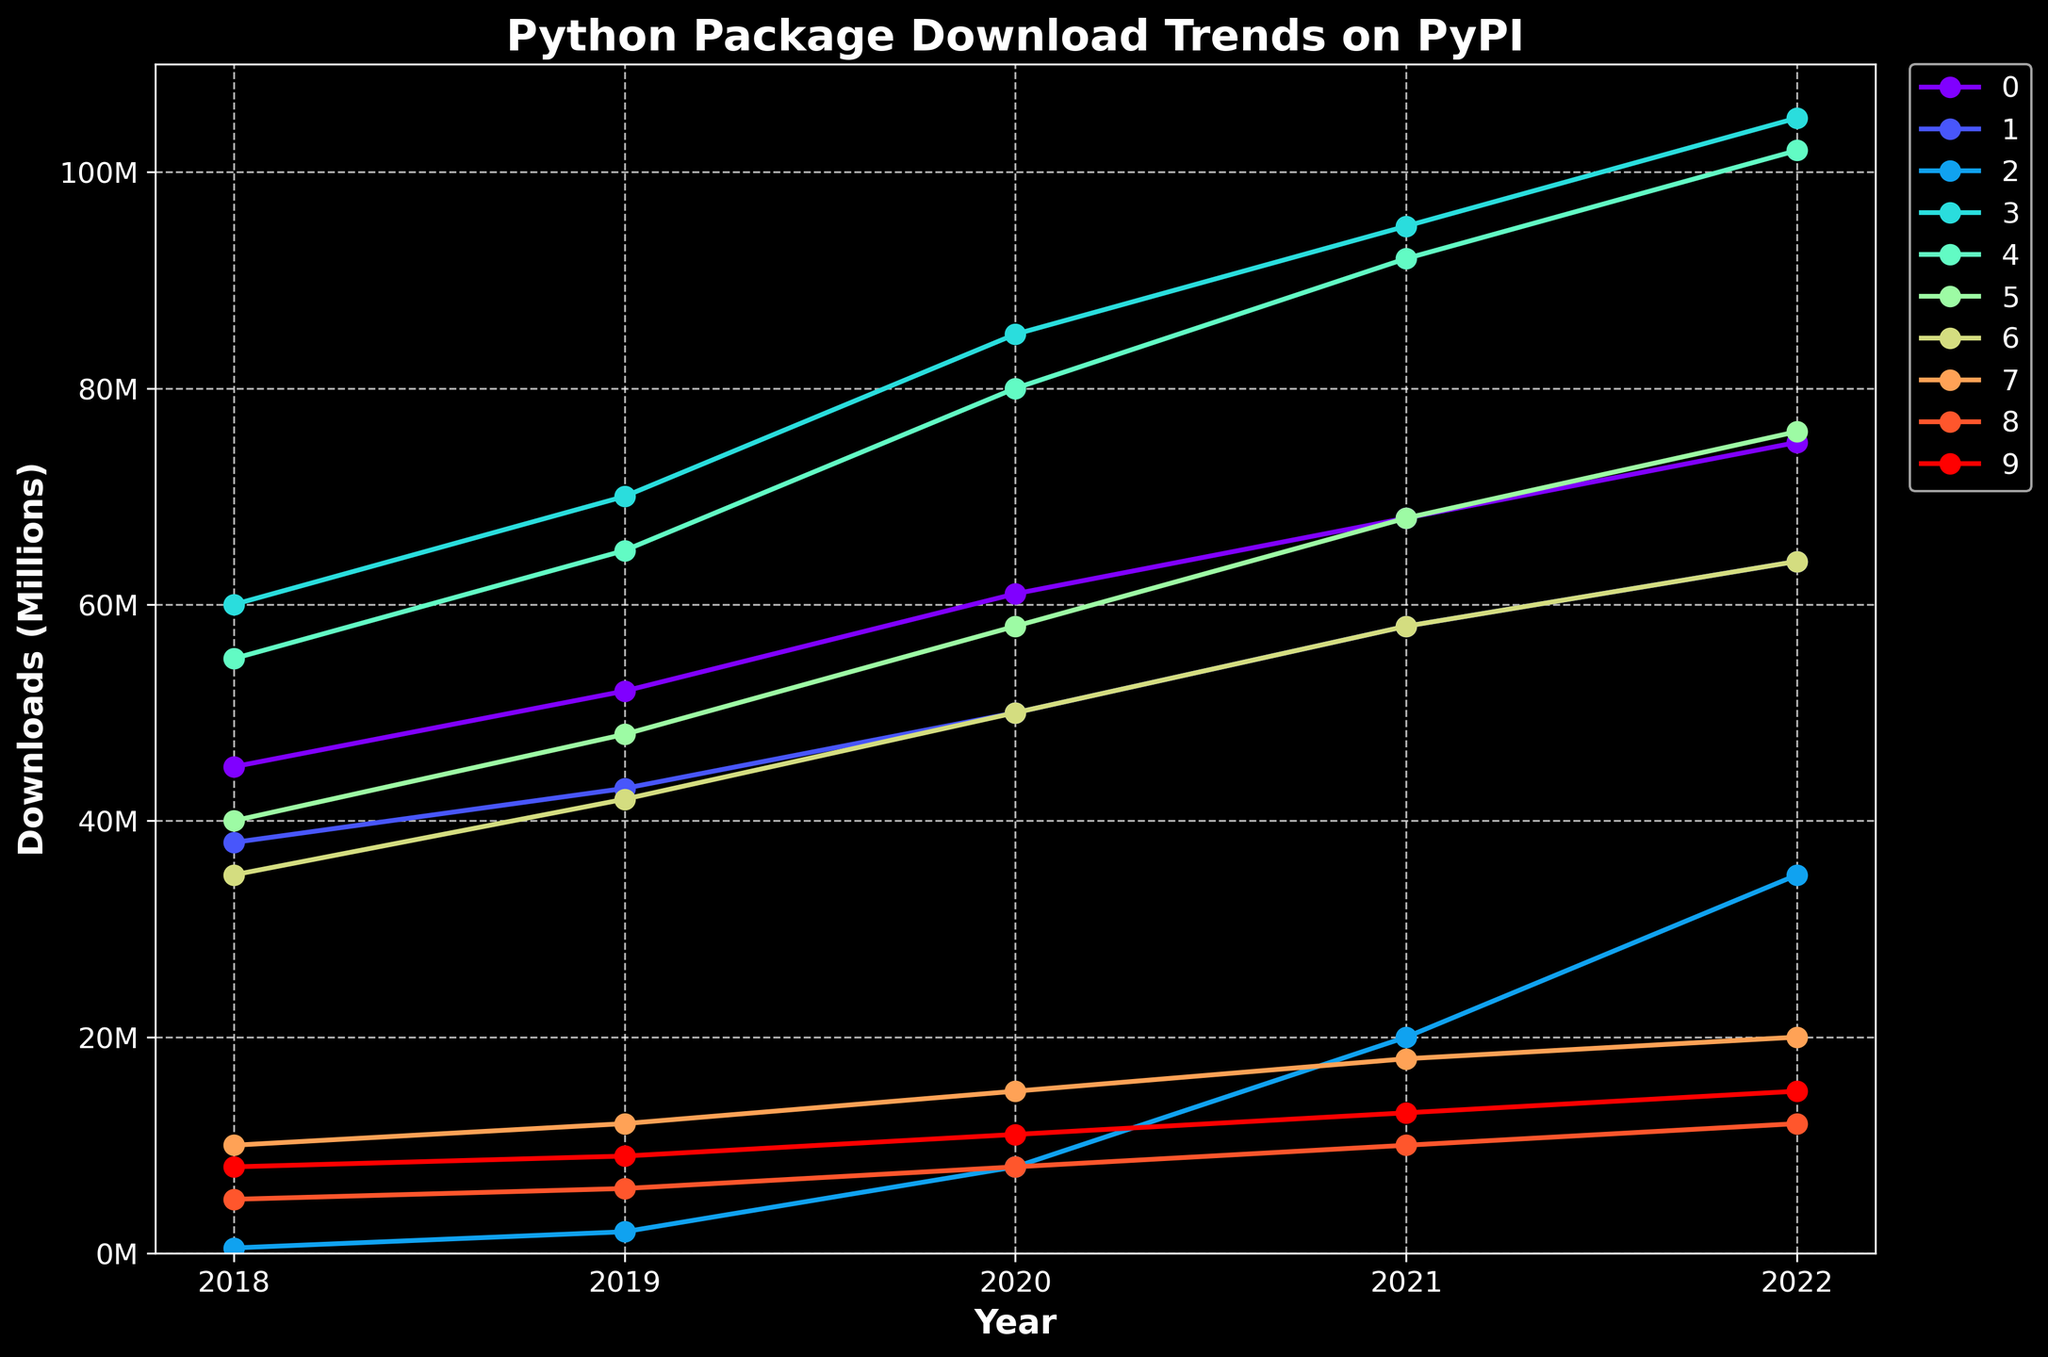What is the highest number of downloads reported for any package in 2022? Look for the package with the highest value in the 2022 column. The highest value is for NumPy with 105,000,000 downloads
Answer: NumPy with 105,000,000 Which package category has shown the most significant increase in downloads from 2018 to 2022? To determine this, calculate the difference between the 2018 and 2022 values for each category and identify the one with the most significant increase. NumPy has increased by 45,000,000 downloads from 2018 to 2022.
Answer: NumPy Between Flask and Django, which package had higher downloads in 2020? Compare the values of Flask and Django for the year 2020. Django has 61,000,000 downloads, whereas Flask has 50,000,000 downloads in 2020.
Answer: Django What is the average number of downloads for Pandas across all years in the chart? Sum the downloads for Pandas across the years and divide by the number of years (5). The sum of downloads is 109,000,000 + 150,000,000 + 240,000,000 + 210,000,000 + 225,000,000 = 934,000,000. The average is 934,000,000 / 5 = 186,800,000
Answer: 74,200,000 Which category had the least downloads in 2019, and what was the value? Identify the category with the smallest value in the 2019 column. FastAPI had the least downloads with 2,000,000 in 2019.
Answer: FastAPI with 2,000,000 How many categories had more than 60,000,000 downloads in 2021? Count the categories with values greater than 60,000,000 in the 2021 column. There are three categories: Django, NumPy, and Pandas.
Answer: 3 In 2021, by how much did NumPy's downloads exceed those of Matplotlib? Subtract the number of downloads for Matplotlib from NumPy in 2021. NumPy had 95,000,000 downloads and Matplotlib had 58,000,000 downloads. The difference is 95,000,000 - 58,000,000 = 37,000,000
Answer: 37,000,000 Between Kivy and Tkinter, which package has shown a more significant overall growth from 2018 to 2022? Calculate the change in downloads from 2018 to 2022 for both packages. Kivy went from 5,000,000 to 12,000,000, an increase of 7,000,000. Tkinter went from 8,000,000 to 15,000,000, an increase of 7,000,000. Therefore, both show the same growth.
Answer: Both have the same growth How many categories crossed the 50,000,000 mark in 2021? Count the number of categories that had more than 50,000,000 downloads in 2021. Django, Flask, NumPy, Pandas, and Scikit-learn all crossed this mark, making it 5 categories.
Answer: 5 